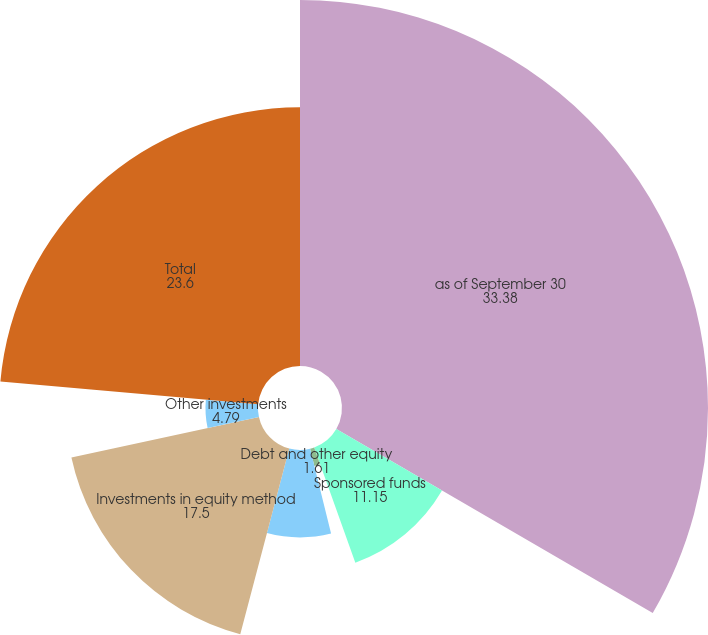Convert chart to OTSL. <chart><loc_0><loc_0><loc_500><loc_500><pie_chart><fcel>as of September 30<fcel>Sponsored funds<fcel>Debt and other equity<fcel>Total investment securities<fcel>Investments in equity method<fcel>Other investments<fcel>Total<nl><fcel>33.38%<fcel>11.15%<fcel>1.61%<fcel>7.97%<fcel>17.5%<fcel>4.79%<fcel>23.6%<nl></chart> 